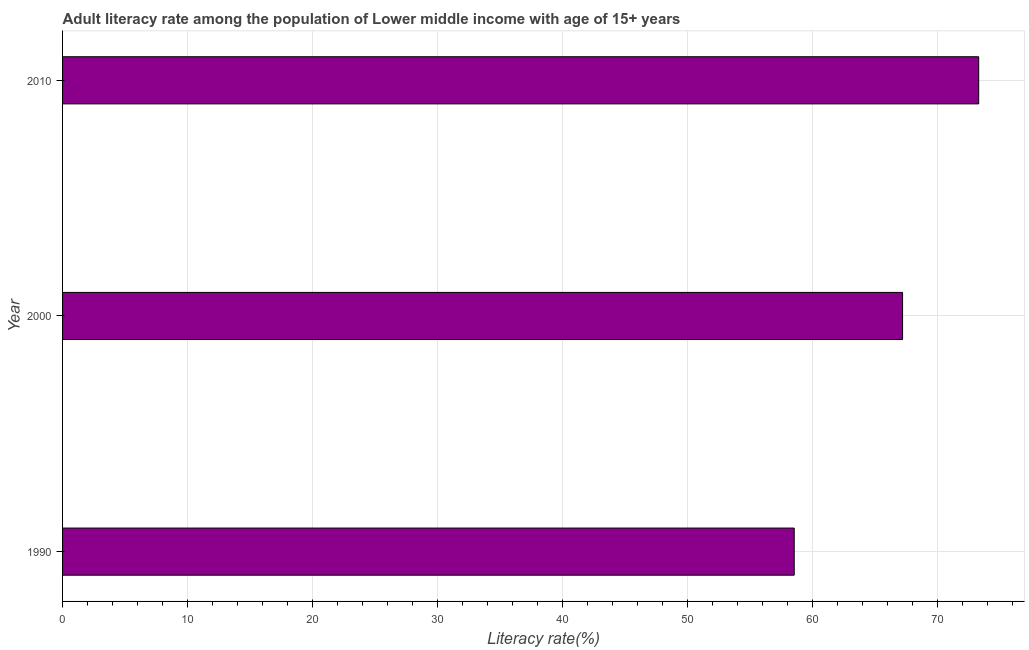Does the graph contain any zero values?
Provide a short and direct response. No. What is the title of the graph?
Offer a terse response. Adult literacy rate among the population of Lower middle income with age of 15+ years. What is the label or title of the X-axis?
Your answer should be compact. Literacy rate(%). What is the adult literacy rate in 1990?
Make the answer very short. 58.51. Across all years, what is the maximum adult literacy rate?
Your answer should be compact. 73.26. Across all years, what is the minimum adult literacy rate?
Your answer should be compact. 58.51. What is the sum of the adult literacy rate?
Offer a very short reply. 198.94. What is the difference between the adult literacy rate in 1990 and 2010?
Give a very brief answer. -14.75. What is the average adult literacy rate per year?
Your response must be concise. 66.31. What is the median adult literacy rate?
Offer a very short reply. 67.17. In how many years, is the adult literacy rate greater than 70 %?
Give a very brief answer. 1. What is the ratio of the adult literacy rate in 1990 to that in 2000?
Offer a terse response. 0.87. What is the difference between the highest and the second highest adult literacy rate?
Your response must be concise. 6.09. Is the sum of the adult literacy rate in 1990 and 2010 greater than the maximum adult literacy rate across all years?
Offer a terse response. Yes. What is the difference between the highest and the lowest adult literacy rate?
Your response must be concise. 14.75. In how many years, is the adult literacy rate greater than the average adult literacy rate taken over all years?
Make the answer very short. 2. Are all the bars in the graph horizontal?
Your answer should be compact. Yes. What is the difference between two consecutive major ticks on the X-axis?
Keep it short and to the point. 10. What is the Literacy rate(%) in 1990?
Make the answer very short. 58.51. What is the Literacy rate(%) of 2000?
Ensure brevity in your answer.  67.17. What is the Literacy rate(%) in 2010?
Your response must be concise. 73.26. What is the difference between the Literacy rate(%) in 1990 and 2000?
Keep it short and to the point. -8.66. What is the difference between the Literacy rate(%) in 1990 and 2010?
Give a very brief answer. -14.75. What is the difference between the Literacy rate(%) in 2000 and 2010?
Ensure brevity in your answer.  -6.09. What is the ratio of the Literacy rate(%) in 1990 to that in 2000?
Keep it short and to the point. 0.87. What is the ratio of the Literacy rate(%) in 1990 to that in 2010?
Your answer should be very brief. 0.8. What is the ratio of the Literacy rate(%) in 2000 to that in 2010?
Make the answer very short. 0.92. 